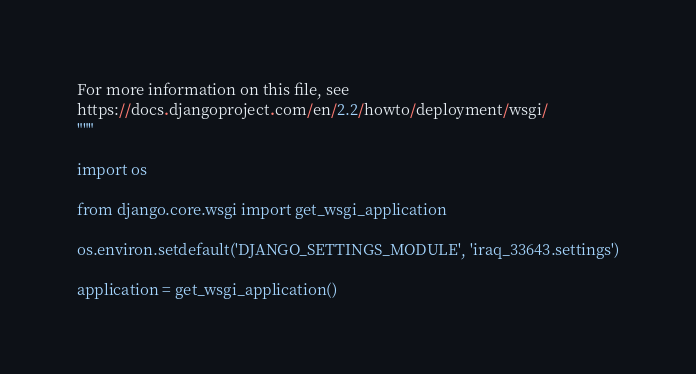Convert code to text. <code><loc_0><loc_0><loc_500><loc_500><_Python_>
For more information on this file, see
https://docs.djangoproject.com/en/2.2/howto/deployment/wsgi/
"""

import os

from django.core.wsgi import get_wsgi_application

os.environ.setdefault('DJANGO_SETTINGS_MODULE', 'iraq_33643.settings')

application = get_wsgi_application()
</code> 